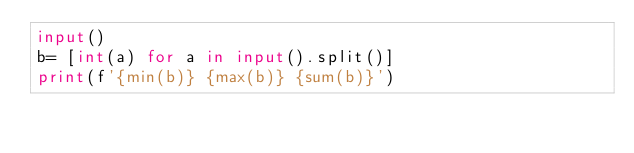<code> <loc_0><loc_0><loc_500><loc_500><_Python_>input()
b= [int(a) for a in input().split()]
print(f'{min(b)} {max(b)} {sum(b)}')</code> 